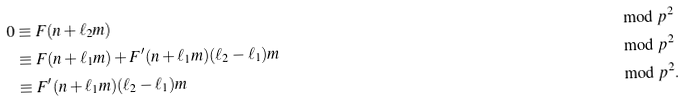Convert formula to latex. <formula><loc_0><loc_0><loc_500><loc_500>0 & \equiv F ( n + \ell _ { 2 } m ) & & \bmod p ^ { 2 } \\ & \equiv F ( n + \ell _ { 1 } m ) + F ^ { \prime } ( n + \ell _ { 1 } m ) ( \ell _ { 2 } - \ell _ { 1 } ) m & & \bmod p ^ { 2 } \\ & \equiv F ^ { \prime } ( n + \ell _ { 1 } m ) ( \ell _ { 2 } - \ell _ { 1 } ) m & & \bmod p ^ { 2 } .</formula> 